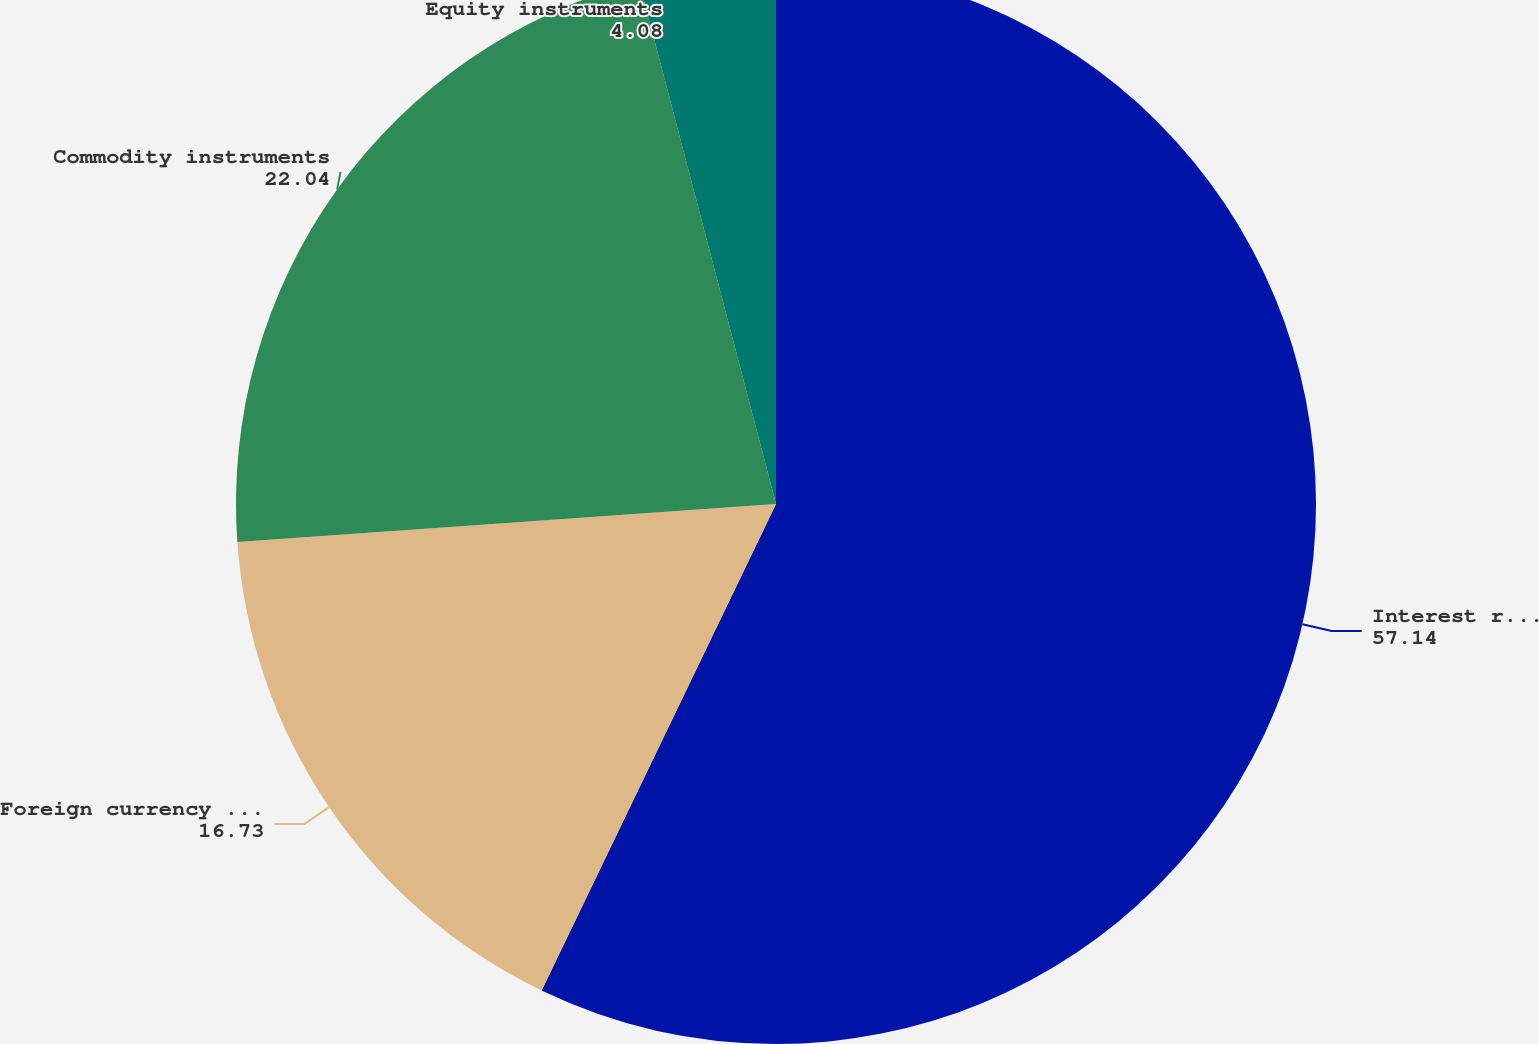<chart> <loc_0><loc_0><loc_500><loc_500><pie_chart><fcel>Interest rate instruments<fcel>Foreign currency instruments<fcel>Commodity instruments<fcel>Equity instruments<nl><fcel>57.14%<fcel>16.73%<fcel>22.04%<fcel>4.08%<nl></chart> 